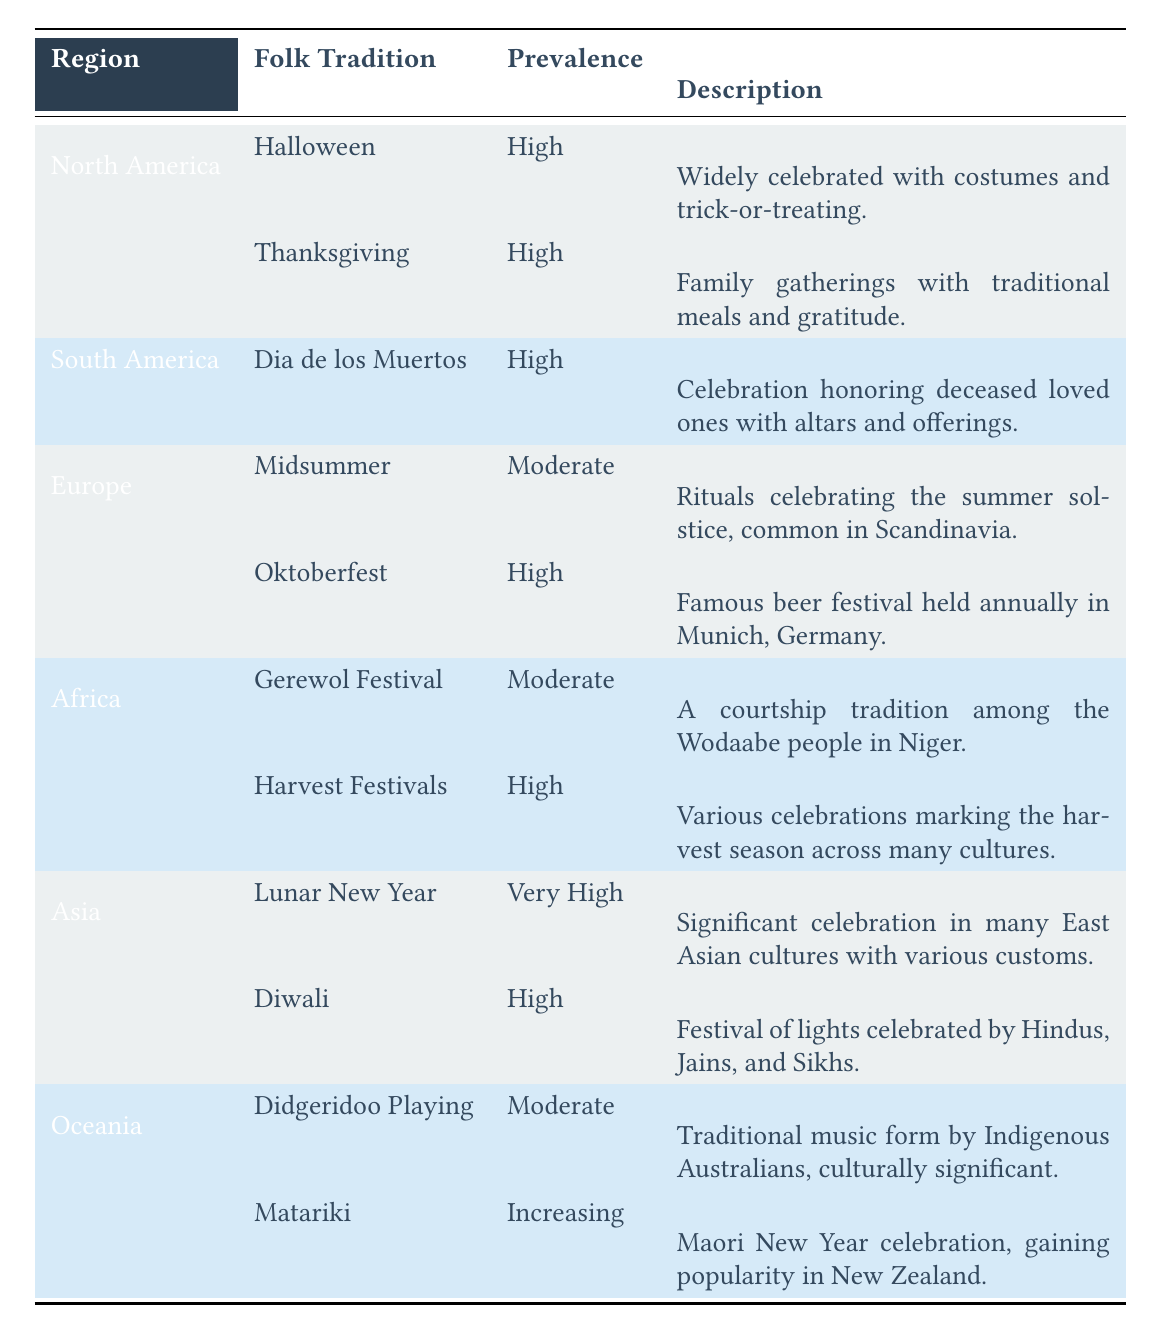What folk tradition in North America has the highest prevalence? According to the table, both Halloween and Thanksgiving are listed under North America with a prevalence of "High." Since the question asks for the one with the highest prevalence, it indicates that both traditions share the same high status.
Answer: Halloween and Thanksgiving Which folk tradition is associated with harvest festivals in Africa? The table indicates that "Harvest Festivals" is a folk tradition in Africa with a prevalence of "High" and is described as various celebrations marking the harvest season across many cultures.
Answer: Harvest Festivals Is the prevalence of Matariki in Oceania increasing? Yes, the table explicitly states that the prevalence of the Matariki tradition in Oceania is "Increasing," which confirms the question.
Answer: Yes How many folk traditions are considered to have very high prevalence across all regions listed? The table shows that there is only one folk tradition with a prevalence of "Very High," which is "Lunar New Year" in the Asia region.
Answer: 1 In which region is Oktoberfest celebrated, and how is its prevalence described? The table lists Oktoberfest under Europe with a prevalence rated as "High," making it a significant folk tradition in that region.
Answer: Europe, High What is the difference in prevalence between the folk traditions of Gerewol Festival and Harvest Festivals in Africa? The Gerewol Festival has a prevalence of "Moderate," while the Harvest Festivals have a prevalence of "High." The difference between these two prevalence levels is one category: Moderate is less than High.
Answer: 1 category Which folk tradition in Asia has a higher prevalence, Diwali or Lunar New Year? The table shows that Lunar New Year has a prevalence of "Very High," while Diwali has a prevalence of "High." Thus, Lunar New Year has a higher prevalence than Diwali.
Answer: Lunar New Year Are there any folk traditions in Oceania with a high prevalence? No, the table indicates that the folk traditions listed for Oceania, Didgeridoo Playing and Matariki, have prevalences of "Moderate" and "Increasing," respectively, making them below the threshold of "High."
Answer: No How many folk traditions in Europe are classified with a moderate prevalence? The table lists Midsummer and Gerewol Festival as two separate folk traditions in Europe. However, Midsummer has a prevalence of "Moderate," while Oktoberfest is rated "High." Therefore, only Midsummer qualifies under moderate.
Answer: 1 